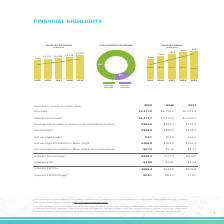According to Black Knight Financial Services's financial document, What was the effect of the company's indirect investment in The Dun and Bradstreet Corporation? a reduction of Net earnings of $73.9 million primarily due to the effect of its purchase accounting adjustments, restructuring charges and other non-operating charges.. The document states: "vestment in The Dun and Bradstreet Corporation was a reduction of Net earnings of $73.9 million primarily due to the effect of its purchase accounting..." Also, What was the revenues in 2018? According to the financial document, 1,114.0 (in millions). The relevant text states: "Revenues $1,177.2 $1,114.0 $1,051.6..." Also, What were the net earnings in 2017? According to the financial document, 254.2 (in millions). The relevant text states: "osses of unconsolidated affiliates $182.8 $168.5 $254.2..." Also, can you calculate: What was the change in net earnings between 2017 and 2018? Based on the calculation: 168.5-254.2, the result is -85.7 (in millions). This is based on the information: "ty in losses of unconsolidated affiliates $182.8 $168.5 $254.2 osses of unconsolidated affiliates $182.8 $168.5 $254.2..." The key data points involved are: 168.5, 254.2. Also, can you calculate: What was the percentage change in the Net earnings margin between 2017 and 2019? Based on the calculation: 9.2-24.2, the result is -15 (percentage). This is based on the information: "Net earnings margin 9.2% 15.1% 24.2% Net earnings margin 9.2% 15.1% 24.2%..." The key data points involved are: 24.2, 9.2. Also, can you calculate: What was the percentage change in revenues between 2018 and 2019? To answer this question, I need to perform calculations using the financial data. The calculation is: (1,177.2-1,114.0)/1,114.0, which equals 5.67 (percentage). This is based on the information: "Revenues $1,177.2 $1,114.0 $1,051.6 Revenues $1,177.2 $1,114.0 $1,051.6..." The key data points involved are: 1,114.0, 1,177.2. 